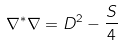Convert formula to latex. <formula><loc_0><loc_0><loc_500><loc_500>\nabla ^ { * } \nabla = D ^ { 2 } - \frac { S } { 4 }</formula> 